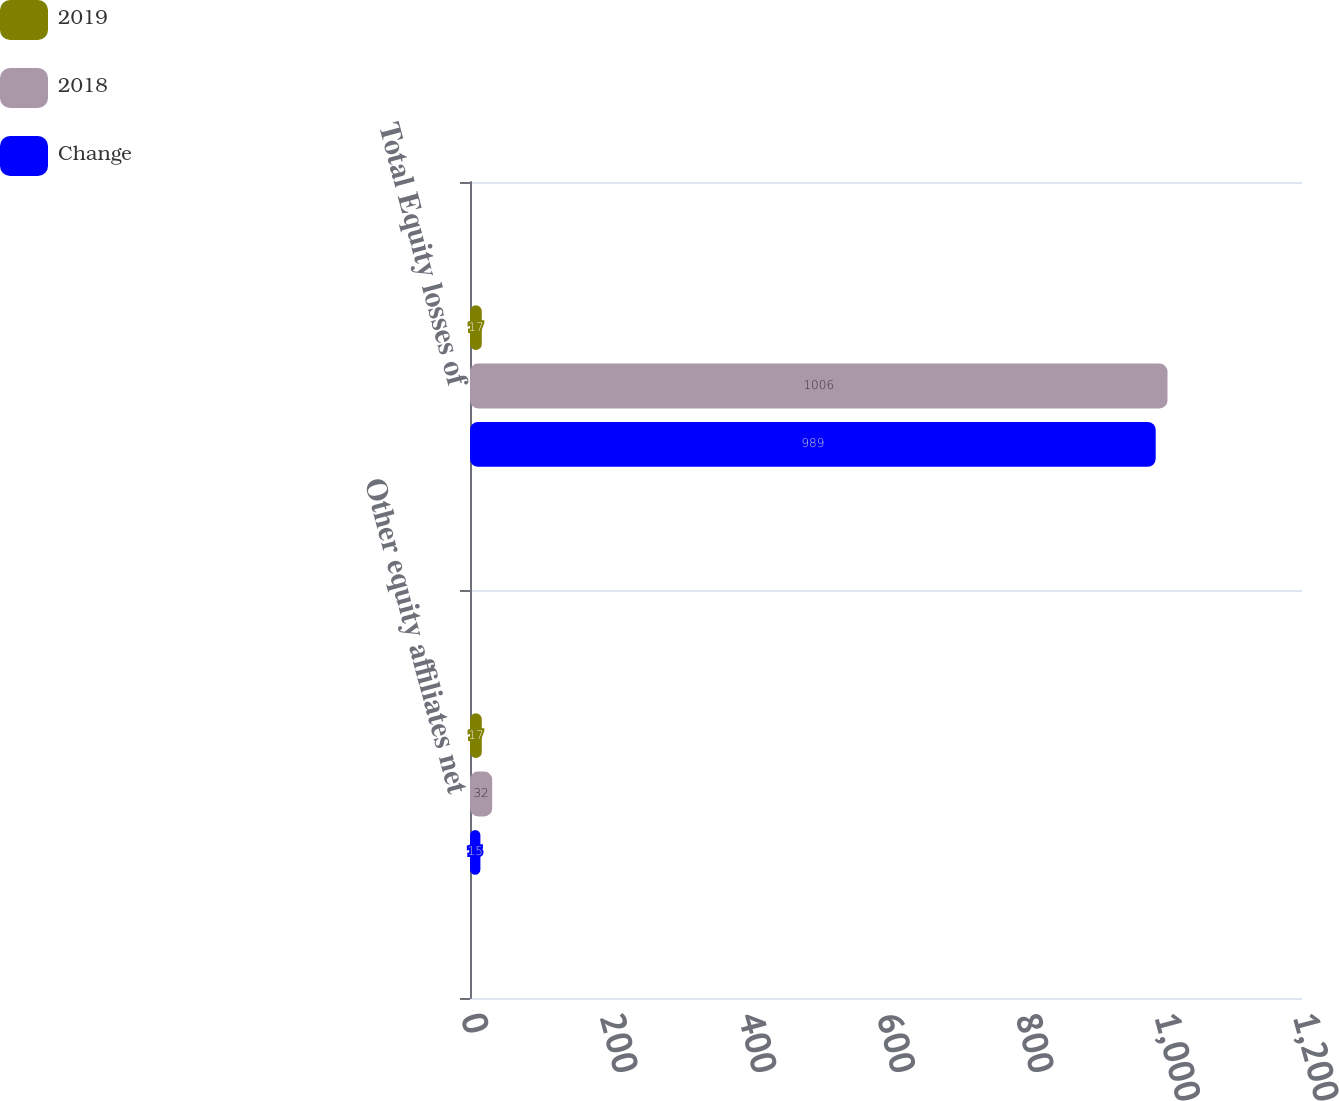Convert chart. <chart><loc_0><loc_0><loc_500><loc_500><stacked_bar_chart><ecel><fcel>Other equity affiliates net<fcel>Total Equity losses of<nl><fcel>2019<fcel>17<fcel>17<nl><fcel>2018<fcel>32<fcel>1006<nl><fcel>Change<fcel>15<fcel>989<nl></chart> 